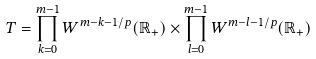<formula> <loc_0><loc_0><loc_500><loc_500>T = \prod _ { k = 0 } ^ { m - 1 } W ^ { m - k - 1 / p } ( \mathbb { R } _ { + } ) \times \prod _ { l = 0 } ^ { m - 1 } W ^ { m - l - 1 / p } ( \mathbb { R } _ { + } )</formula> 